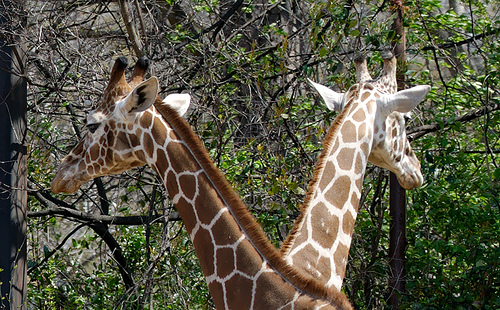<image>
Can you confirm if the giraffe is on the tree? No. The giraffe is not positioned on the tree. They may be near each other, but the giraffe is not supported by or resting on top of the tree. Is there a giraffe in front of the giraffe? Yes. The giraffe is positioned in front of the giraffe, appearing closer to the camera viewpoint. 